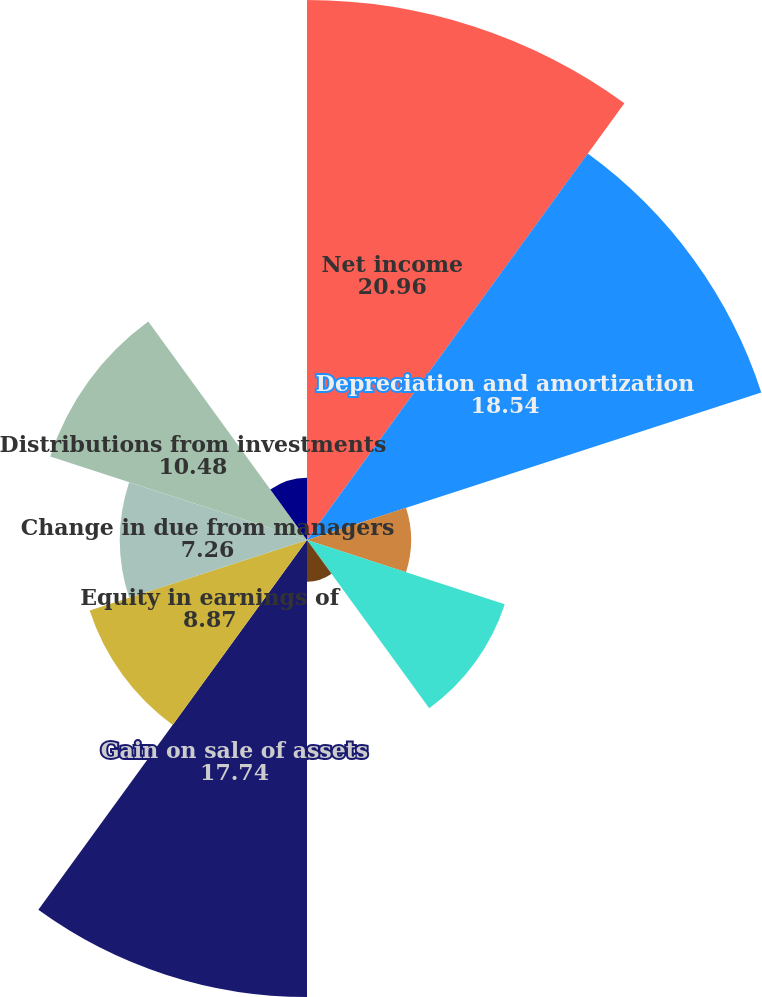Convert chart. <chart><loc_0><loc_0><loc_500><loc_500><pie_chart><fcel>Net income<fcel>Depreciation and amortization<fcel>Amortization of finance costs<fcel>Stock compensation expense<fcel>Deferred income taxes<fcel>Gain on sale of assets<fcel>Equity in earnings of<fcel>Change in due from managers<fcel>Distributions from investments<fcel>Changes in other assets<nl><fcel>20.96%<fcel>18.54%<fcel>4.04%<fcel>8.07%<fcel>1.62%<fcel>17.74%<fcel>8.87%<fcel>7.26%<fcel>10.48%<fcel>2.42%<nl></chart> 